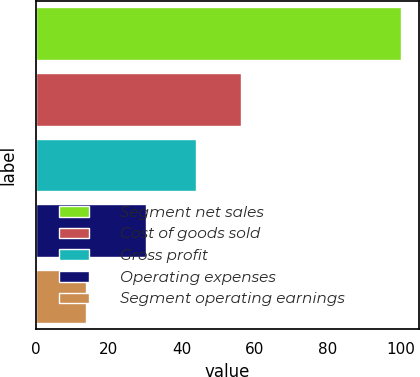Convert chart to OTSL. <chart><loc_0><loc_0><loc_500><loc_500><bar_chart><fcel>Segment net sales<fcel>Cost of goods sold<fcel>Gross profit<fcel>Operating expenses<fcel>Segment operating earnings<nl><fcel>100<fcel>56.1<fcel>43.9<fcel>30.2<fcel>13.7<nl></chart> 